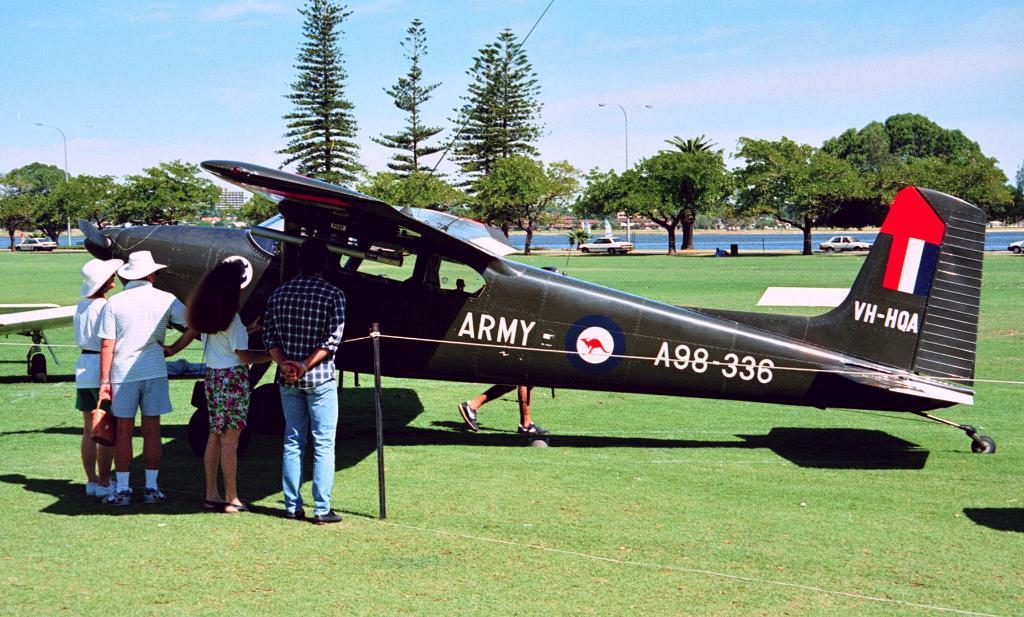Is this an army plane?
Give a very brief answer. Yes. What plane number is this?
Your answer should be compact. A98-336. 